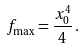<formula> <loc_0><loc_0><loc_500><loc_500>f _ { \max } = \frac { x _ { 0 } ^ { 4 } } { 4 } \, .</formula> 